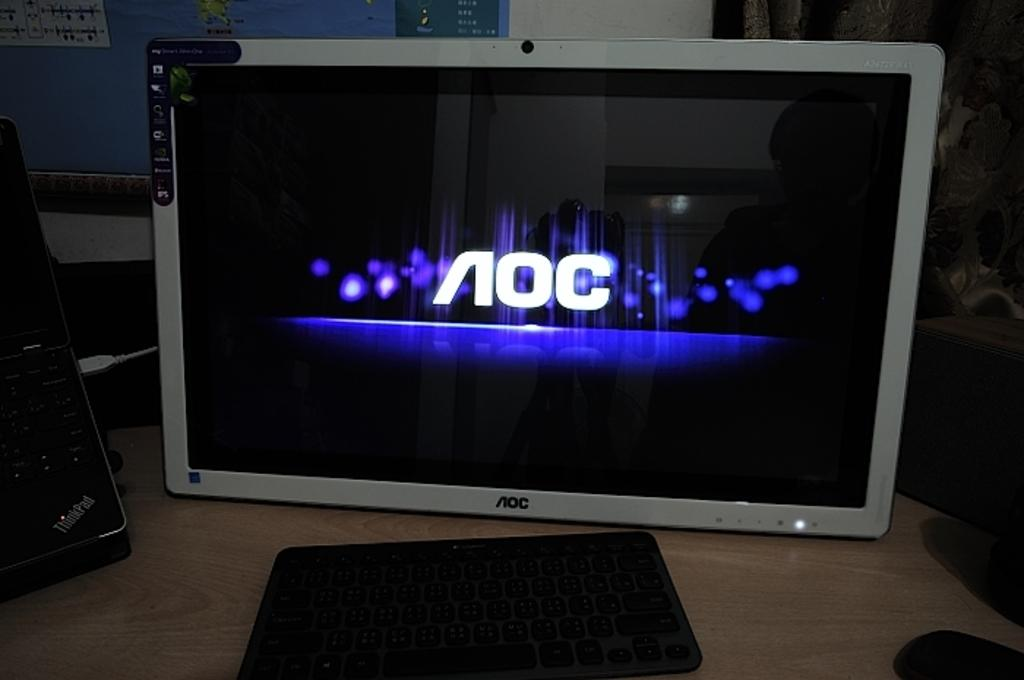<image>
Present a compact description of the photo's key features. A ThinkPad logo can be seen on a device next to a screen. 